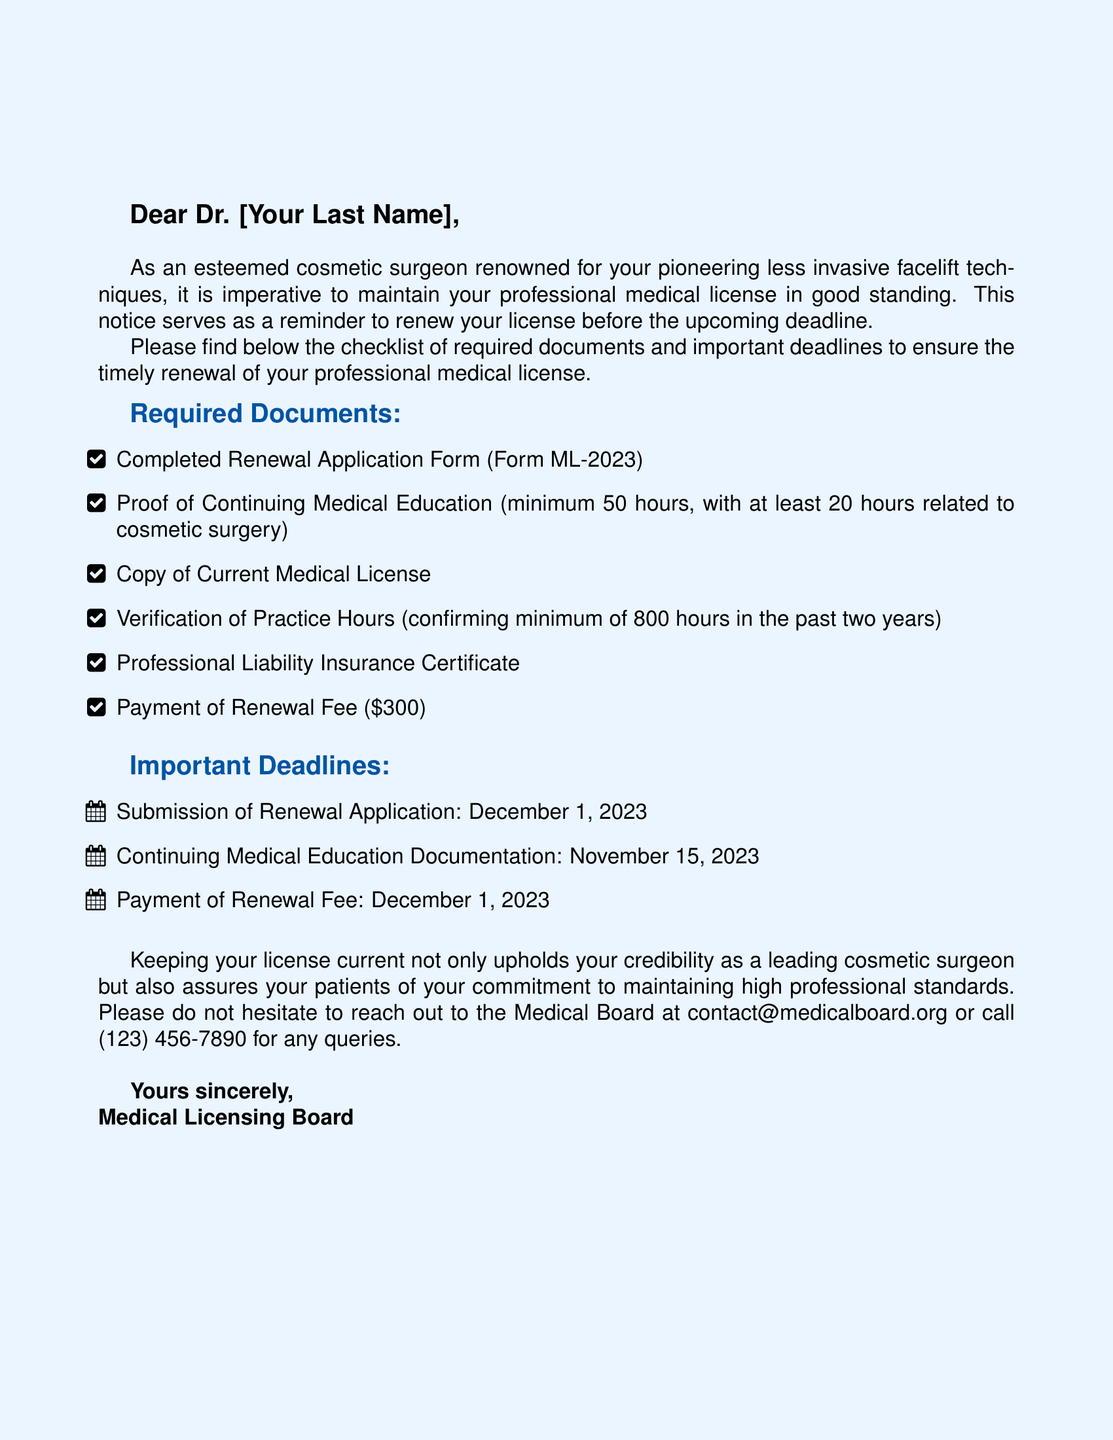What is the deadline for the submission of the renewal application? The deadline for submission of the renewal application is clearly stated in the document.
Answer: December 1, 2023 How many hours of Continuing Medical Education are required? The document specifies a minimum number of hours needed for Continuing Medical Education.
Answer: 50 hours What form is required for renewal? The document lists the complete name of the renewal application form that needs to be completed.
Answer: Form ML-2023 What is the payment amount for the renewal fee? The document explicitly states the cost associated with the renewal fee.
Answer: $300 How many practice hours are required in the past two years? The document outlines the minimum practice hours needed for verification.
Answer: 800 hours What specific area must be included in the Continuing Medical Education hours? The document specifies a particular focus for a portion of the required education hours.
Answer: Cosmetic surgery Who is the sender of the notice? The document concludes with the identity of the organization sending the renewal notice.
Answer: Medical Licensing Board What is the contact email for queries? The document provides a specific contact method for any questions or clarifications.
Answer: contact@medicalboard.org 